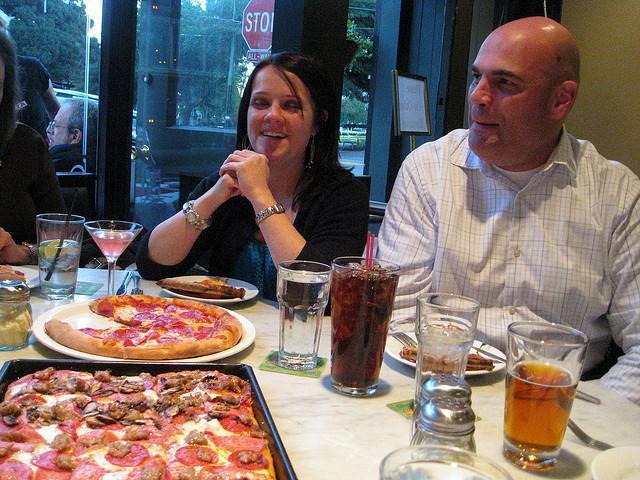How many pizzas have been taken from the pizza?
Give a very brief answer. 1. How many cups are in the picture?
Give a very brief answer. 5. How many pizzas are there?
Give a very brief answer. 2. How many people are there?
Give a very brief answer. 4. 